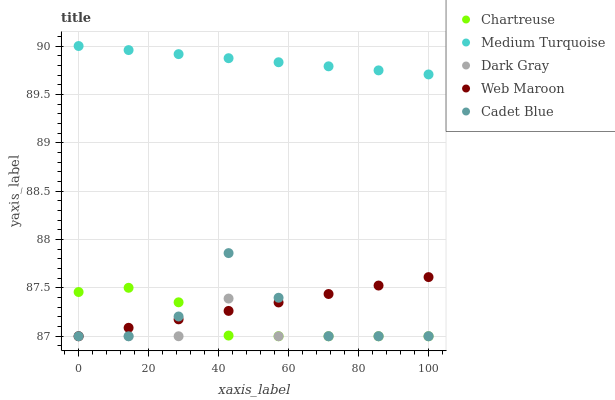Does Dark Gray have the minimum area under the curve?
Answer yes or no. Yes. Does Medium Turquoise have the maximum area under the curve?
Answer yes or no. Yes. Does Chartreuse have the minimum area under the curve?
Answer yes or no. No. Does Chartreuse have the maximum area under the curve?
Answer yes or no. No. Is Web Maroon the smoothest?
Answer yes or no. Yes. Is Cadet Blue the roughest?
Answer yes or no. Yes. Is Chartreuse the smoothest?
Answer yes or no. No. Is Chartreuse the roughest?
Answer yes or no. No. Does Dark Gray have the lowest value?
Answer yes or no. Yes. Does Medium Turquoise have the lowest value?
Answer yes or no. No. Does Medium Turquoise have the highest value?
Answer yes or no. Yes. Does Chartreuse have the highest value?
Answer yes or no. No. Is Web Maroon less than Medium Turquoise?
Answer yes or no. Yes. Is Medium Turquoise greater than Dark Gray?
Answer yes or no. Yes. Does Dark Gray intersect Cadet Blue?
Answer yes or no. Yes. Is Dark Gray less than Cadet Blue?
Answer yes or no. No. Is Dark Gray greater than Cadet Blue?
Answer yes or no. No. Does Web Maroon intersect Medium Turquoise?
Answer yes or no. No. 